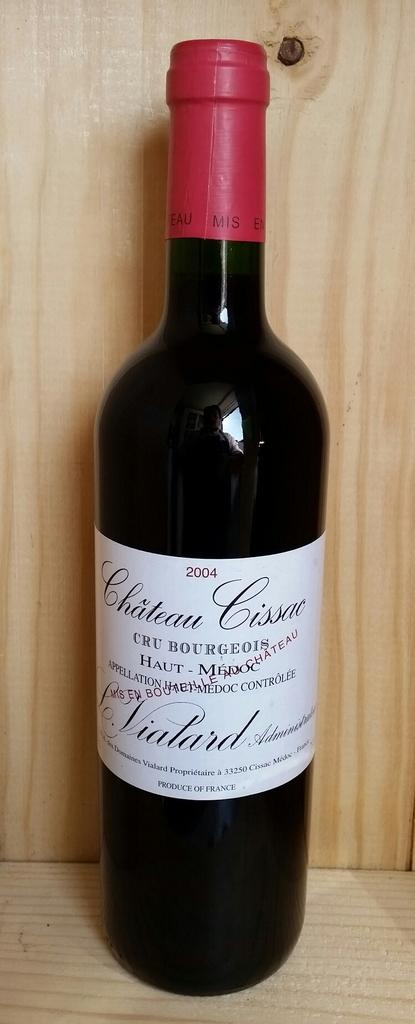Provide a one-sentence caption for the provided image. A bottle of Chateau Cissac was bottled in the year 2004. 